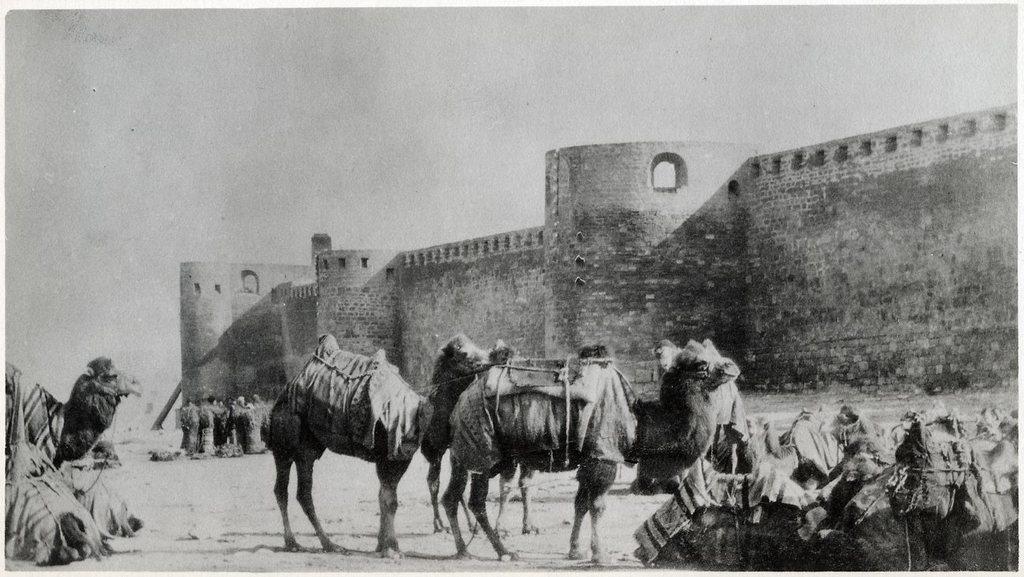In one or two sentences, can you explain what this image depicts? This is a black and white image. In this picture we can see a fort and a group of people are standing and also we can see the horse. At the bottom of the image we can see the ground. At the top of the image we can see the sky. 